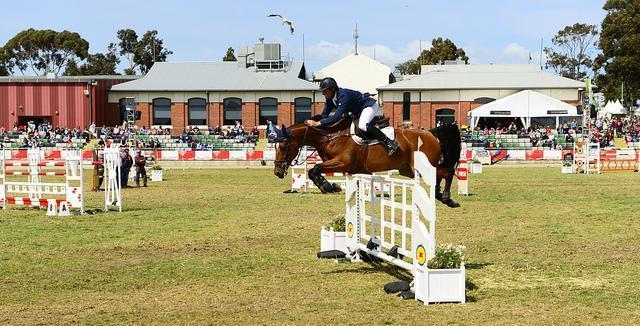How many people are in the photo?
Give a very brief answer. 2. How many bowls are in the picture?
Give a very brief answer. 0. 